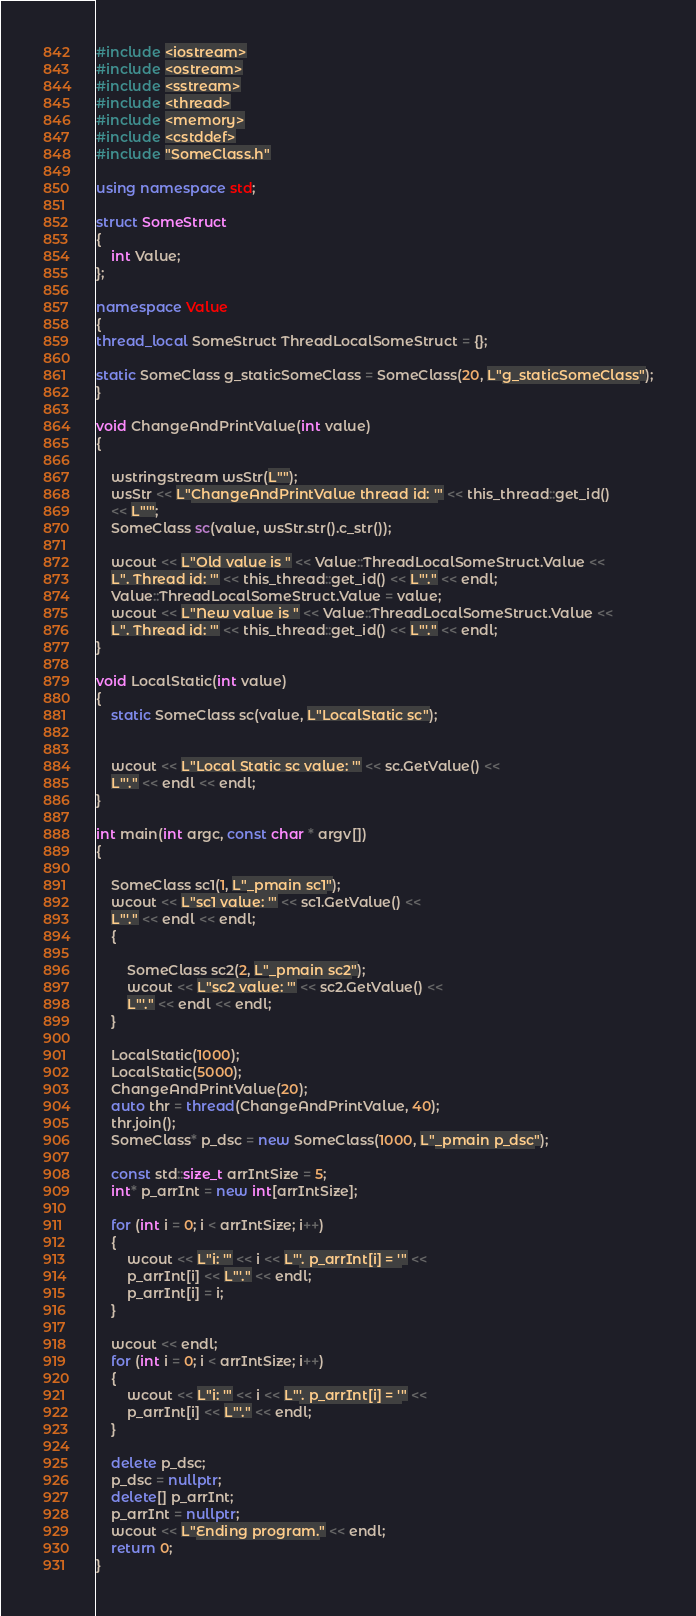Convert code to text. <code><loc_0><loc_0><loc_500><loc_500><_C++_>#include <iostream>
#include <ostream>
#include <sstream>
#include <thread>
#include <memory>
#include <cstddef>
#include "SomeClass.h"

using namespace std;

struct SomeStruct
{
    int Value;
};

namespace Value
{
thread_local SomeStruct ThreadLocalSomeStruct = {};

static SomeClass g_staticSomeClass = SomeClass(20, L"g_staticSomeClass");
}

void ChangeAndPrintValue(int value)
{
    
    wstringstream wsStr(L"");
    wsStr << L"ChangeAndPrintValue thread id: '" << this_thread::get_id()
    << L"'";
    SomeClass sc(value, wsStr.str().c_str());
    
    wcout << L"Old value is " << Value::ThreadLocalSomeStruct.Value <<
    L". Thread id: '" << this_thread::get_id() << L"'." << endl;
    Value::ThreadLocalSomeStruct.Value = value;
    wcout << L"New value is " << Value::ThreadLocalSomeStruct.Value <<
    L". Thread id: '" << this_thread::get_id() << L"'." << endl;
}

void LocalStatic(int value)
{
    static SomeClass sc(value, L"LocalStatic sc");
    
    
    wcout << L"Local Static sc value: '" << sc.GetValue() <<
    L"'." << endl << endl;
}

int main(int argc, const char * argv[])
{
    
    SomeClass sc1(1, L"_pmain sc1");
    wcout << L"sc1 value: '" << sc1.GetValue() <<
    L"'." << endl << endl;
    {
        
        SomeClass sc2(2, L"_pmain sc2");
        wcout << L"sc2 value: '" << sc2.GetValue() <<
        L"'." << endl << endl;
    }
    
    LocalStatic(1000);
    LocalStatic(5000);
    ChangeAndPrintValue(20);
    auto thr = thread(ChangeAndPrintValue, 40);
    thr.join();
    SomeClass* p_dsc = new SomeClass(1000, L"_pmain p_dsc");
    
    const std::size_t arrIntSize = 5;
    int* p_arrInt = new int[arrIntSize];
    
    for (int i = 0; i < arrIntSize; i++)
    {
        wcout << L"i: '" << i << L"'. p_arrInt[i] = '" <<
        p_arrInt[i] << L"'." << endl;
        p_arrInt[i] = i;
    }
    
    wcout << endl;
    for (int i = 0; i < arrIntSize; i++)
    {
        wcout << L"i: '" << i << L"'. p_arrInt[i] = '" <<
        p_arrInt[i] << L"'." << endl;
    }
    
    delete p_dsc;
    p_dsc = nullptr;
    delete[] p_arrInt;
    p_arrInt = nullptr;
    wcout << L"Ending program." << endl;
    return 0;
}
</code> 